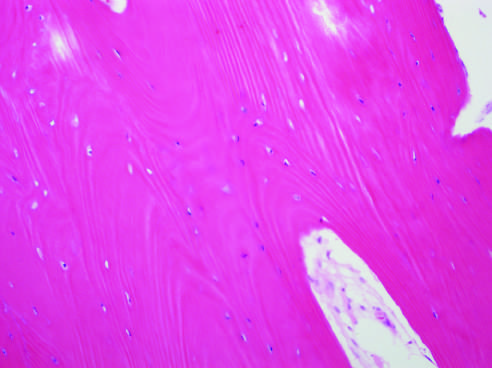s fig.653 more cellular and disorganized than this?
Answer the question using a single word or phrase. No 